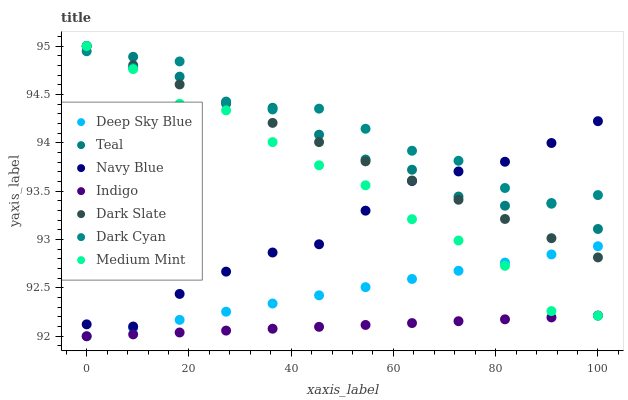Does Indigo have the minimum area under the curve?
Answer yes or no. Yes. Does Dark Cyan have the maximum area under the curve?
Answer yes or no. Yes. Does Deep Sky Blue have the minimum area under the curve?
Answer yes or no. No. Does Deep Sky Blue have the maximum area under the curve?
Answer yes or no. No. Is Deep Sky Blue the smoothest?
Answer yes or no. Yes. Is Dark Cyan the roughest?
Answer yes or no. Yes. Is Indigo the smoothest?
Answer yes or no. No. Is Indigo the roughest?
Answer yes or no. No. Does Indigo have the lowest value?
Answer yes or no. Yes. Does Navy Blue have the lowest value?
Answer yes or no. No. Does Teal have the highest value?
Answer yes or no. Yes. Does Deep Sky Blue have the highest value?
Answer yes or no. No. Is Deep Sky Blue less than Dark Cyan?
Answer yes or no. Yes. Is Navy Blue greater than Deep Sky Blue?
Answer yes or no. Yes. Does Dark Cyan intersect Medium Mint?
Answer yes or no. Yes. Is Dark Cyan less than Medium Mint?
Answer yes or no. No. Is Dark Cyan greater than Medium Mint?
Answer yes or no. No. Does Deep Sky Blue intersect Dark Cyan?
Answer yes or no. No. 